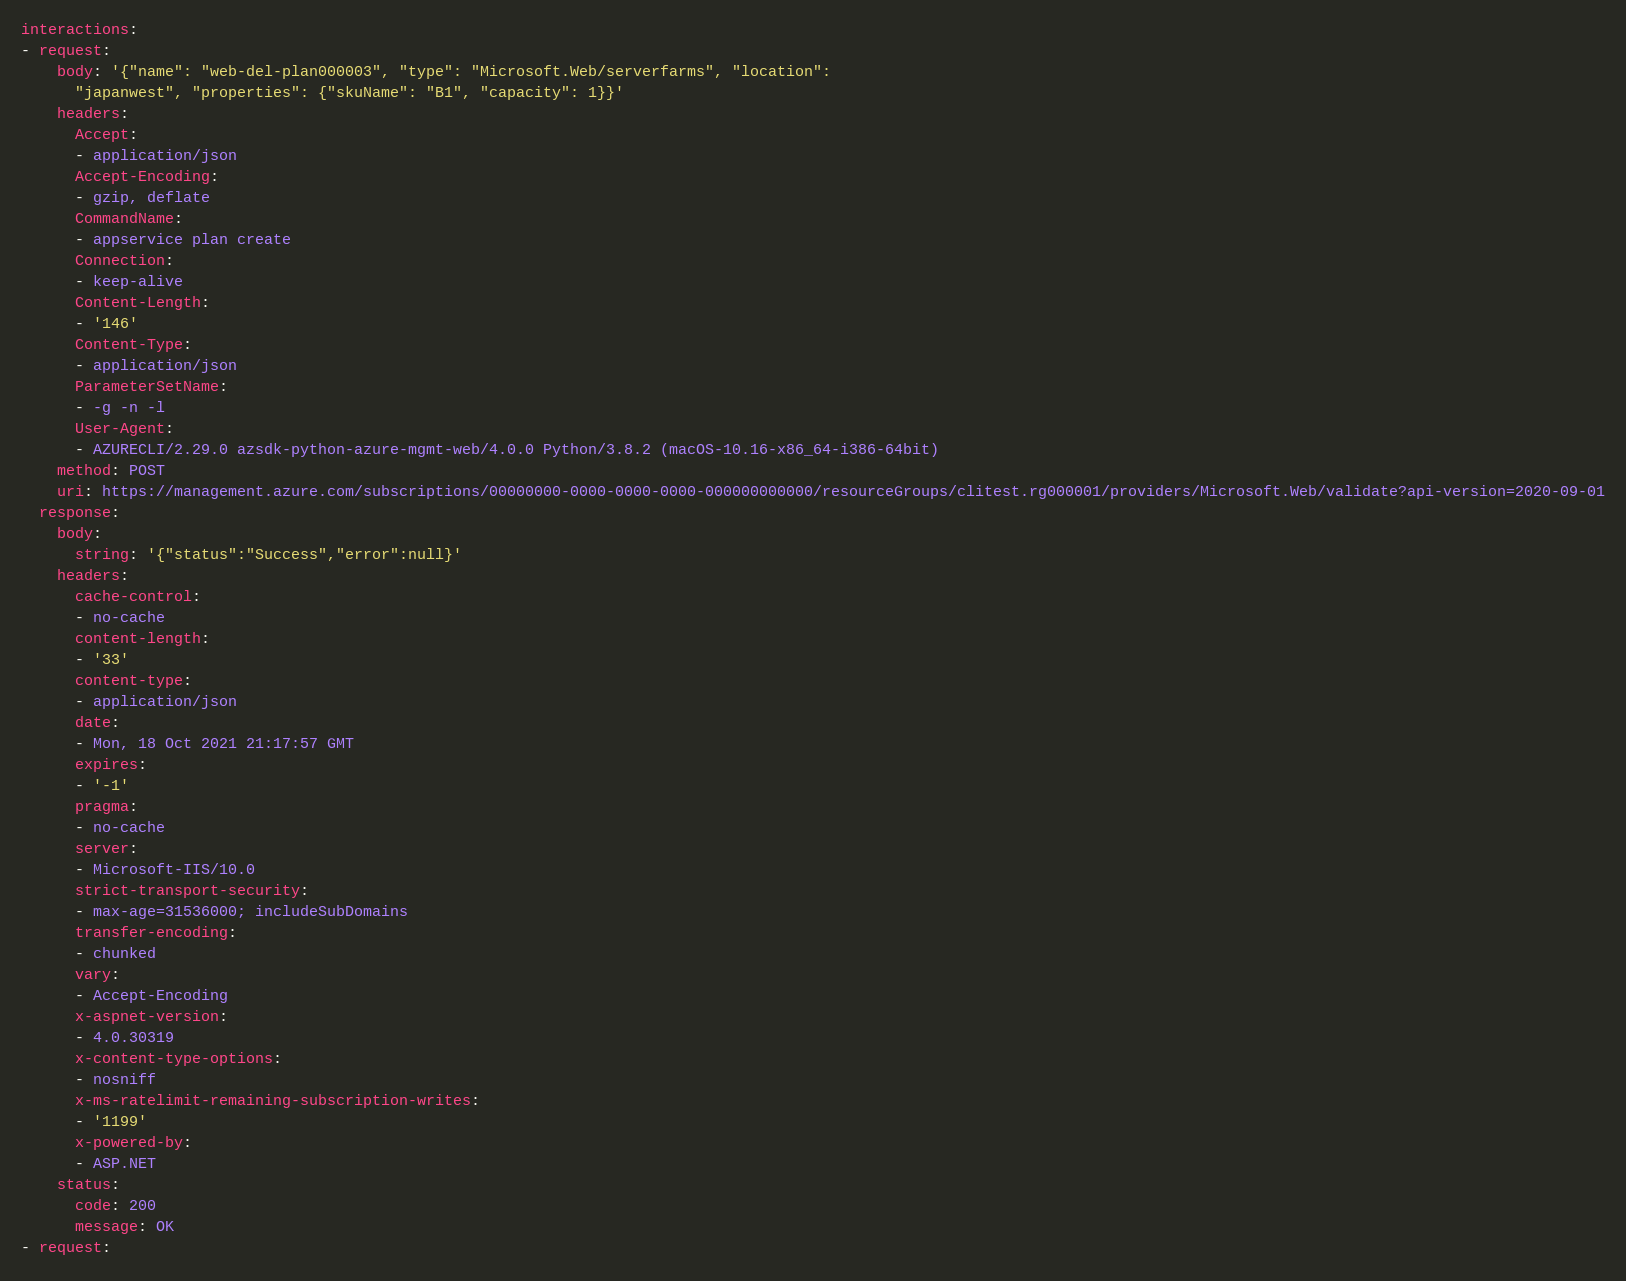<code> <loc_0><loc_0><loc_500><loc_500><_YAML_>interactions:
- request:
    body: '{"name": "web-del-plan000003", "type": "Microsoft.Web/serverfarms", "location":
      "japanwest", "properties": {"skuName": "B1", "capacity": 1}}'
    headers:
      Accept:
      - application/json
      Accept-Encoding:
      - gzip, deflate
      CommandName:
      - appservice plan create
      Connection:
      - keep-alive
      Content-Length:
      - '146'
      Content-Type:
      - application/json
      ParameterSetName:
      - -g -n -l
      User-Agent:
      - AZURECLI/2.29.0 azsdk-python-azure-mgmt-web/4.0.0 Python/3.8.2 (macOS-10.16-x86_64-i386-64bit)
    method: POST
    uri: https://management.azure.com/subscriptions/00000000-0000-0000-0000-000000000000/resourceGroups/clitest.rg000001/providers/Microsoft.Web/validate?api-version=2020-09-01
  response:
    body:
      string: '{"status":"Success","error":null}'
    headers:
      cache-control:
      - no-cache
      content-length:
      - '33'
      content-type:
      - application/json
      date:
      - Mon, 18 Oct 2021 21:17:57 GMT
      expires:
      - '-1'
      pragma:
      - no-cache
      server:
      - Microsoft-IIS/10.0
      strict-transport-security:
      - max-age=31536000; includeSubDomains
      transfer-encoding:
      - chunked
      vary:
      - Accept-Encoding
      x-aspnet-version:
      - 4.0.30319
      x-content-type-options:
      - nosniff
      x-ms-ratelimit-remaining-subscription-writes:
      - '1199'
      x-powered-by:
      - ASP.NET
    status:
      code: 200
      message: OK
- request:</code> 